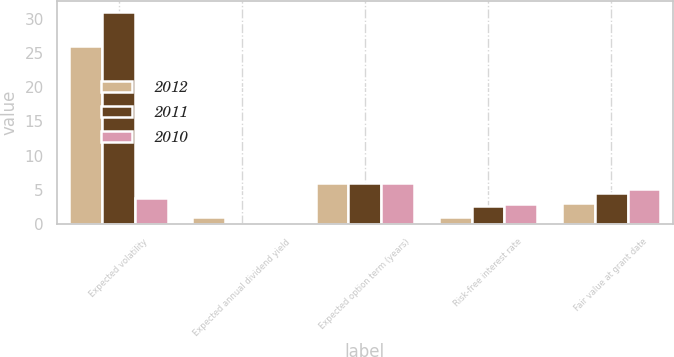Convert chart to OTSL. <chart><loc_0><loc_0><loc_500><loc_500><stacked_bar_chart><ecel><fcel>Expected volatility<fcel>Expected annual dividend yield<fcel>Expected option term (years)<fcel>Risk-free interest rate<fcel>Fair value at grant date<nl><fcel>2012<fcel>26<fcel>1<fcel>6<fcel>1.08<fcel>3.04<nl><fcel>2011<fcel>31<fcel>0<fcel>6<fcel>2.65<fcel>4.54<nl><fcel>2010<fcel>3.79<fcel>0<fcel>6<fcel>2.86<fcel>5.08<nl></chart> 